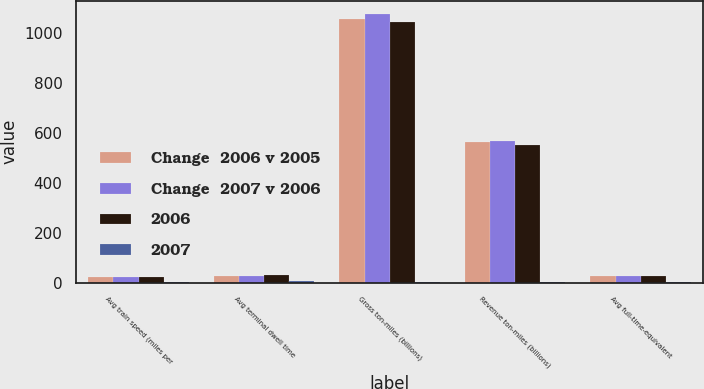Convert chart to OTSL. <chart><loc_0><loc_0><loc_500><loc_500><stacked_bar_chart><ecel><fcel>Avg train speed (miles per<fcel>Avg terminal dwell time<fcel>Gross ton-miles (billions)<fcel>Revenue ton-miles (billions)<fcel>Avg full-time-equivalent<nl><fcel>Change  2006 v 2005<fcel>21.8<fcel>25.1<fcel>1052.3<fcel>561.8<fcel>25.1<nl><fcel>Change  2007 v 2006<fcel>21.4<fcel>27.2<fcel>1072.5<fcel>565.2<fcel>25.1<nl><fcel>2006<fcel>21.1<fcel>28.7<fcel>1043.9<fcel>548.8<fcel>25.1<nl><fcel>2007<fcel>2<fcel>8<fcel>2<fcel>1<fcel>1<nl></chart> 